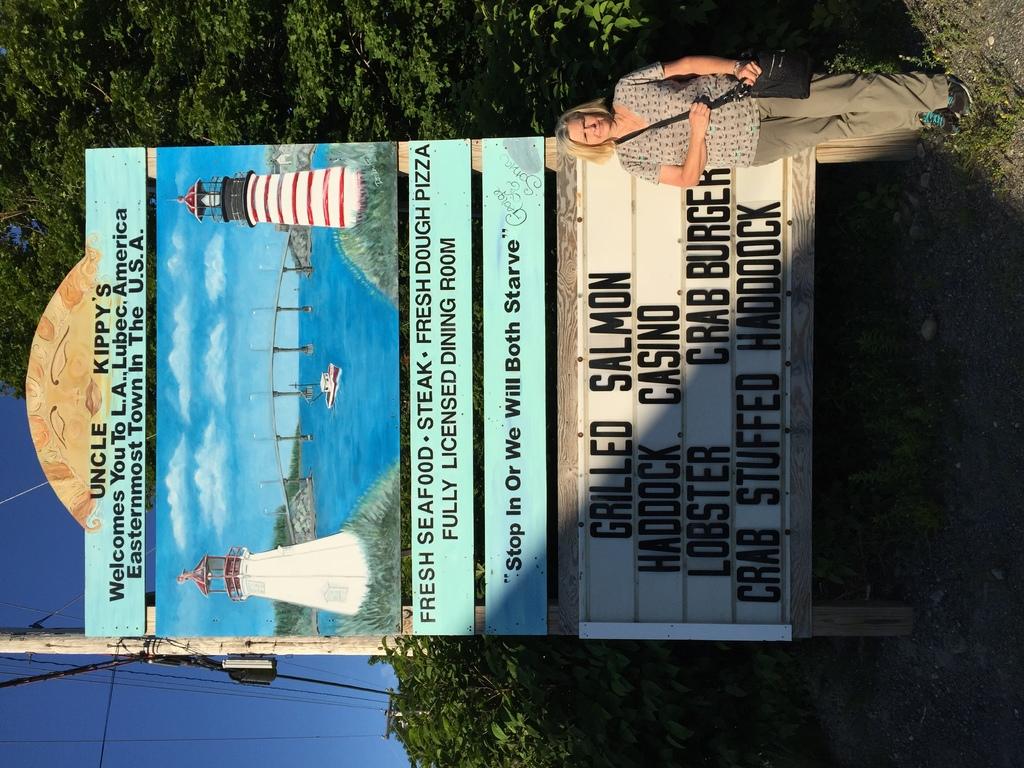What fish is being served?
Your response must be concise. Grilled salmon. What is fresh according to the sign?
Your answer should be compact. Seafood. 